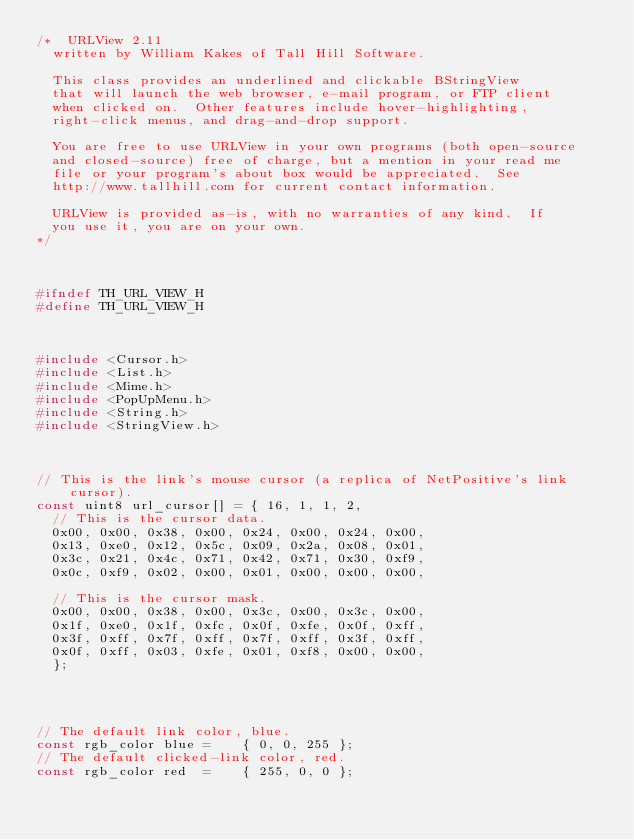Convert code to text. <code><loc_0><loc_0><loc_500><loc_500><_C_>/*  URLView 2.11
	written by William Kakes of Tall Hill Software.
	
	This class provides an underlined and clickable BStringView
	that will launch the web browser, e-mail program, or FTP client
	when clicked on.  Other features include hover-highlighting,
	right-click	menus, and drag-and-drop support.

	You are free to use URLView in your own programs (both open-source
	and closed-source) free of charge, but a mention in your read me
	file or your program's about box would be appreciated.  See
	http://www.tallhill.com	for current contact information.
	
	URLView is provided as-is, with no warranties of any kind.  If
	you use it, you are on your own.
*/



#ifndef TH_URL_VIEW_H
#define TH_URL_VIEW_H



#include <Cursor.h>
#include <List.h>
#include <Mime.h>
#include <PopUpMenu.h>
#include <String.h>
#include <StringView.h>



// This is the link's mouse cursor (a replica of NetPositive's link cursor).
const uint8 url_cursor[] = { 16, 1, 1, 2,
	// This is the cursor data.
	0x00, 0x00, 0x38, 0x00, 0x24, 0x00, 0x24, 0x00,
	0x13, 0xe0,	0x12, 0x5c,	0x09, 0x2a,	0x08, 0x01,
	0x3c, 0x21,	0x4c, 0x71,	0x42, 0x71,	0x30, 0xf9,
	0x0c, 0xf9,	0x02, 0x00,	0x01, 0x00,	0x00, 0x00,
	
	// This is the cursor mask.
	0x00, 0x00,	0x38, 0x00,	0x3c, 0x00,	0x3c, 0x00,
	0x1f, 0xe0,	0x1f, 0xfc, 0x0f, 0xfe,	0x0f, 0xff,
	0x3f, 0xff,	0x7f, 0xff,	0x7f, 0xff,	0x3f, 0xff,
	0x0f, 0xff,	0x03, 0xfe,	0x01, 0xf8,	0x00, 0x00,
	};




// The default link color, blue.
const rgb_color blue =		{ 0, 0, 255 };
// The default clicked-link color, red.
const rgb_color red  =		{ 255, 0, 0 };</code> 